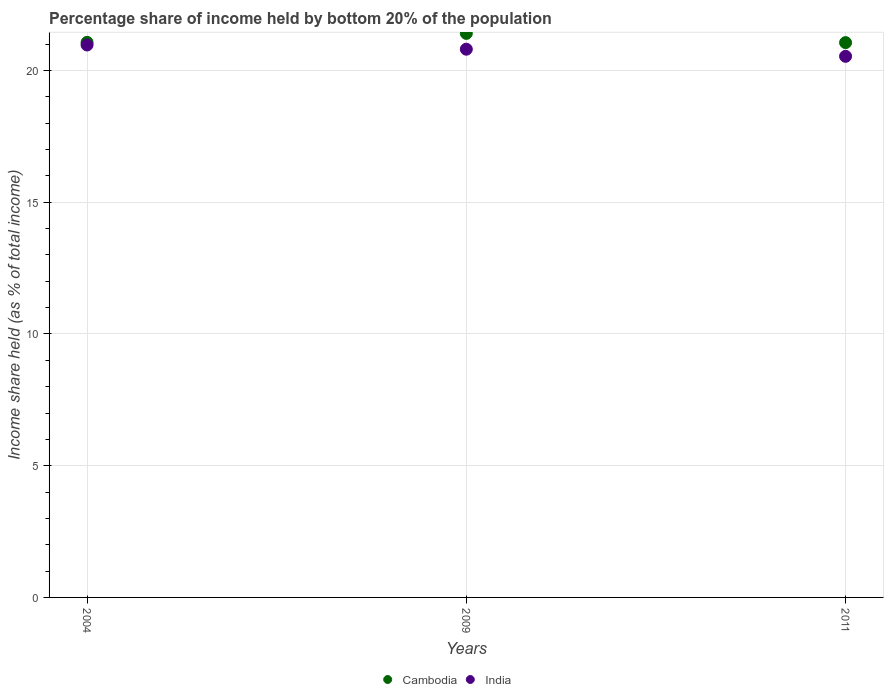How many different coloured dotlines are there?
Ensure brevity in your answer.  2. Is the number of dotlines equal to the number of legend labels?
Offer a very short reply. Yes. What is the share of income held by bottom 20% of the population in Cambodia in 2004?
Your response must be concise. 21.07. Across all years, what is the maximum share of income held by bottom 20% of the population in India?
Your response must be concise. 20.97. Across all years, what is the minimum share of income held by bottom 20% of the population in India?
Your answer should be compact. 20.54. In which year was the share of income held by bottom 20% of the population in India maximum?
Give a very brief answer. 2004. In which year was the share of income held by bottom 20% of the population in Cambodia minimum?
Offer a terse response. 2011. What is the total share of income held by bottom 20% of the population in Cambodia in the graph?
Provide a succinct answer. 63.54. What is the difference between the share of income held by bottom 20% of the population in India in 2004 and that in 2011?
Your answer should be compact. 0.43. What is the average share of income held by bottom 20% of the population in Cambodia per year?
Ensure brevity in your answer.  21.18. In the year 2009, what is the difference between the share of income held by bottom 20% of the population in India and share of income held by bottom 20% of the population in Cambodia?
Make the answer very short. -0.6. What is the ratio of the share of income held by bottom 20% of the population in Cambodia in 2004 to that in 2011?
Keep it short and to the point. 1. What is the difference between the highest and the second highest share of income held by bottom 20% of the population in India?
Provide a short and direct response. 0.16. What is the difference between the highest and the lowest share of income held by bottom 20% of the population in India?
Ensure brevity in your answer.  0.43. In how many years, is the share of income held by bottom 20% of the population in India greater than the average share of income held by bottom 20% of the population in India taken over all years?
Your answer should be compact. 2. Is the sum of the share of income held by bottom 20% of the population in India in 2004 and 2011 greater than the maximum share of income held by bottom 20% of the population in Cambodia across all years?
Your response must be concise. Yes. Is the share of income held by bottom 20% of the population in India strictly less than the share of income held by bottom 20% of the population in Cambodia over the years?
Offer a very short reply. Yes. Are the values on the major ticks of Y-axis written in scientific E-notation?
Offer a very short reply. No. How are the legend labels stacked?
Give a very brief answer. Horizontal. What is the title of the graph?
Offer a terse response. Percentage share of income held by bottom 20% of the population. What is the label or title of the Y-axis?
Give a very brief answer. Income share held (as % of total income). What is the Income share held (as % of total income) of Cambodia in 2004?
Keep it short and to the point. 21.07. What is the Income share held (as % of total income) of India in 2004?
Provide a short and direct response. 20.97. What is the Income share held (as % of total income) in Cambodia in 2009?
Give a very brief answer. 21.41. What is the Income share held (as % of total income) in India in 2009?
Keep it short and to the point. 20.81. What is the Income share held (as % of total income) in Cambodia in 2011?
Make the answer very short. 21.06. What is the Income share held (as % of total income) of India in 2011?
Your answer should be compact. 20.54. Across all years, what is the maximum Income share held (as % of total income) of Cambodia?
Provide a short and direct response. 21.41. Across all years, what is the maximum Income share held (as % of total income) in India?
Offer a very short reply. 20.97. Across all years, what is the minimum Income share held (as % of total income) of Cambodia?
Your response must be concise. 21.06. Across all years, what is the minimum Income share held (as % of total income) in India?
Make the answer very short. 20.54. What is the total Income share held (as % of total income) of Cambodia in the graph?
Offer a very short reply. 63.54. What is the total Income share held (as % of total income) in India in the graph?
Keep it short and to the point. 62.32. What is the difference between the Income share held (as % of total income) in Cambodia in 2004 and that in 2009?
Give a very brief answer. -0.34. What is the difference between the Income share held (as % of total income) in India in 2004 and that in 2009?
Give a very brief answer. 0.16. What is the difference between the Income share held (as % of total income) in India in 2004 and that in 2011?
Your answer should be very brief. 0.43. What is the difference between the Income share held (as % of total income) in India in 2009 and that in 2011?
Provide a succinct answer. 0.27. What is the difference between the Income share held (as % of total income) of Cambodia in 2004 and the Income share held (as % of total income) of India in 2009?
Make the answer very short. 0.26. What is the difference between the Income share held (as % of total income) of Cambodia in 2004 and the Income share held (as % of total income) of India in 2011?
Keep it short and to the point. 0.53. What is the difference between the Income share held (as % of total income) of Cambodia in 2009 and the Income share held (as % of total income) of India in 2011?
Your response must be concise. 0.87. What is the average Income share held (as % of total income) of Cambodia per year?
Provide a short and direct response. 21.18. What is the average Income share held (as % of total income) in India per year?
Provide a succinct answer. 20.77. In the year 2009, what is the difference between the Income share held (as % of total income) of Cambodia and Income share held (as % of total income) of India?
Your answer should be compact. 0.6. In the year 2011, what is the difference between the Income share held (as % of total income) of Cambodia and Income share held (as % of total income) of India?
Offer a very short reply. 0.52. What is the ratio of the Income share held (as % of total income) of Cambodia in 2004 to that in 2009?
Your answer should be very brief. 0.98. What is the ratio of the Income share held (as % of total income) in India in 2004 to that in 2009?
Your answer should be very brief. 1.01. What is the ratio of the Income share held (as % of total income) in Cambodia in 2004 to that in 2011?
Offer a terse response. 1. What is the ratio of the Income share held (as % of total income) of India in 2004 to that in 2011?
Provide a succinct answer. 1.02. What is the ratio of the Income share held (as % of total income) of Cambodia in 2009 to that in 2011?
Offer a terse response. 1.02. What is the ratio of the Income share held (as % of total income) in India in 2009 to that in 2011?
Your answer should be compact. 1.01. What is the difference between the highest and the second highest Income share held (as % of total income) of Cambodia?
Ensure brevity in your answer.  0.34. What is the difference between the highest and the second highest Income share held (as % of total income) of India?
Your response must be concise. 0.16. What is the difference between the highest and the lowest Income share held (as % of total income) in India?
Provide a short and direct response. 0.43. 